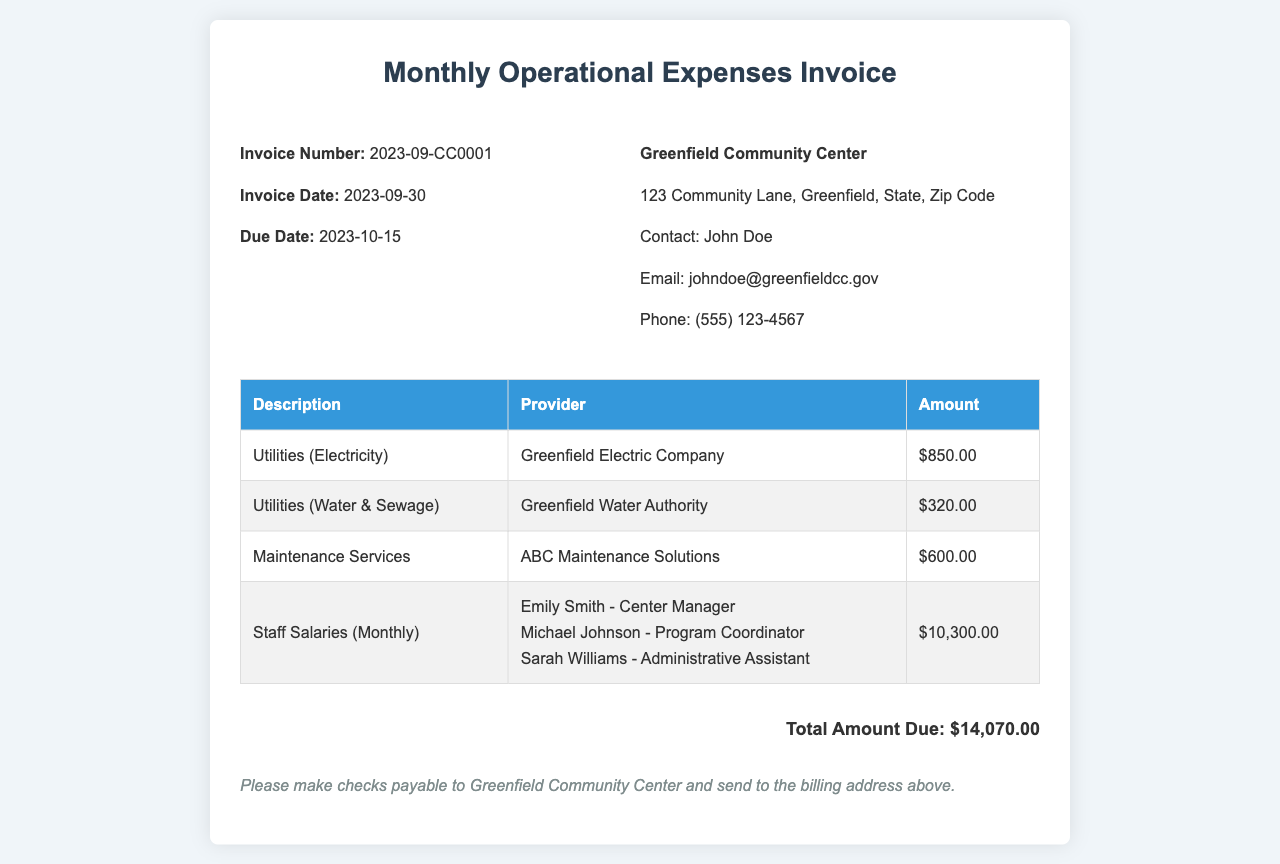what is the invoice number? The invoice number is listed in the invoice details section and is used for tracking and reference purposes.
Answer: 2023-09-CC0001 what is the total amount due? The total amount due is calculated by summing up all the expenses listed in the invoice table.
Answer: $14,070.00 who is the center manager? The center manager is listed among the staff salaries in the invoice and is responsible for managing the community center.
Answer: Emily Smith what is the due date for the invoice? The due date is specified in the invoice details section and indicates when the payment must be made.
Answer: 2023-10-15 how much is allocated for maintenance services? The amount for maintenance services is stated in the invoice table alongside the provider name.
Answer: $600.00 which company provides water and sewage services? The provider of water and sewage services is detailed next to the corresponding expense in the invoice table.
Answer: Greenfield Water Authority how many staff members' salaries are included in the invoice? The salaries section lists the staff members and provides details about their roles, which contributes to the total salary amount.
Answer: 3 what is the invoice date? The invoice date is important for understanding when the charges were billed and for record-keeping purposes.
Answer: 2023-09-30 what are the payment instructions for this invoice? The payment instructions indicate how and where the payment should be made, ensuring proper processing of funds.
Answer: Please make checks payable to Greenfield Community Center and send to the billing address above 